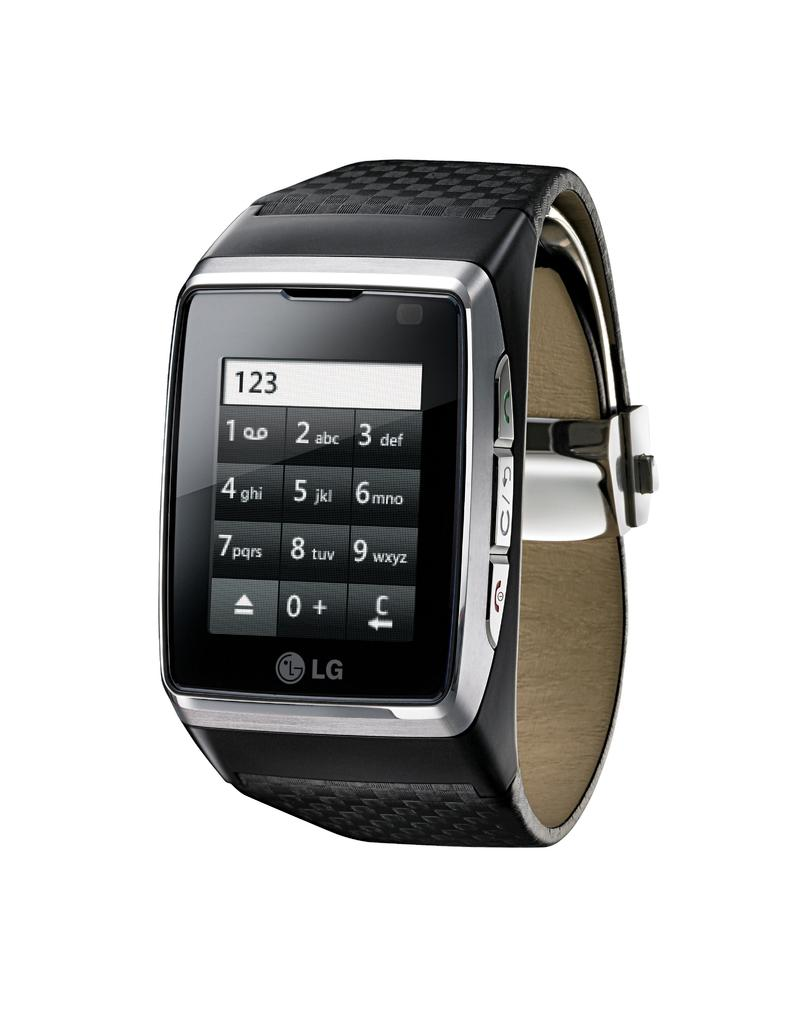What type of watch is in the image? There is a black color digital wrist watch in the image. What is attached to the watch to keep it on the wrist? The wrist watch has a strap. What feature allows the user to interact with the watch? The wrist watch has buttons. What is the color of the background in the image? The background of the image is white. How many fingers are visible on the wrist of the person wearing the watch in the image? There is no person wearing the watch in the image, so it is not possible to determine how many fingers are visible. 